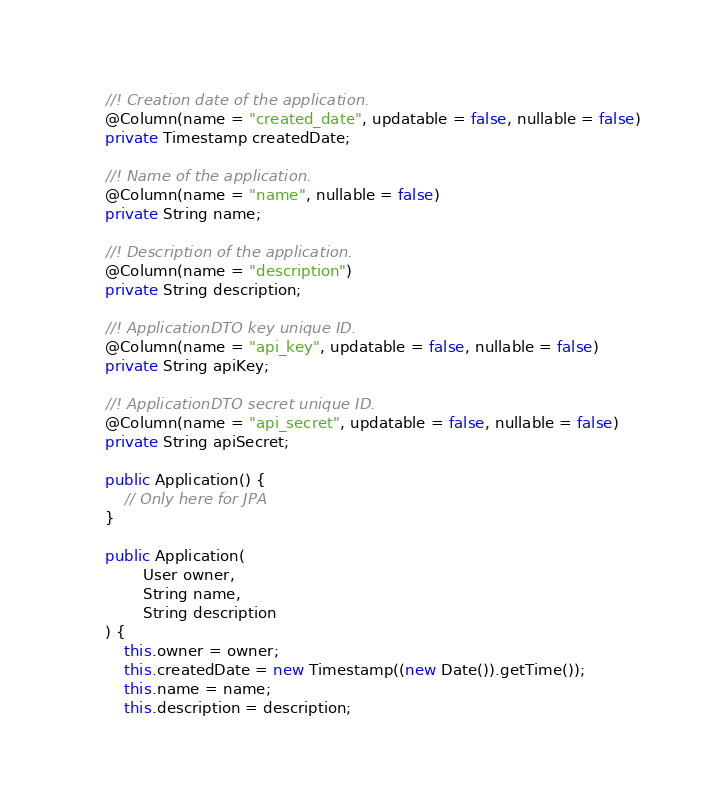Convert code to text. <code><loc_0><loc_0><loc_500><loc_500><_Java_>    //! Creation date of the application.
    @Column(name = "created_date", updatable = false, nullable = false)
    private Timestamp createdDate;

    //! Name of the application.
    @Column(name = "name", nullable = false)
    private String name;

    //! Description of the application.
    @Column(name = "description")
    private String description;

    //! ApplicationDTO key unique ID.
    @Column(name = "api_key", updatable = false, nullable = false)
    private String apiKey;

    //! ApplicationDTO secret unique ID.
    @Column(name = "api_secret", updatable = false, nullable = false)
    private String apiSecret;

    public Application() {
        // Only here for JPA
    }

    public Application(
            User owner,
            String name,
            String description
    ) {
        this.owner = owner;
        this.createdDate = new Timestamp((new Date()).getTime());
        this.name = name;
        this.description = description;</code> 